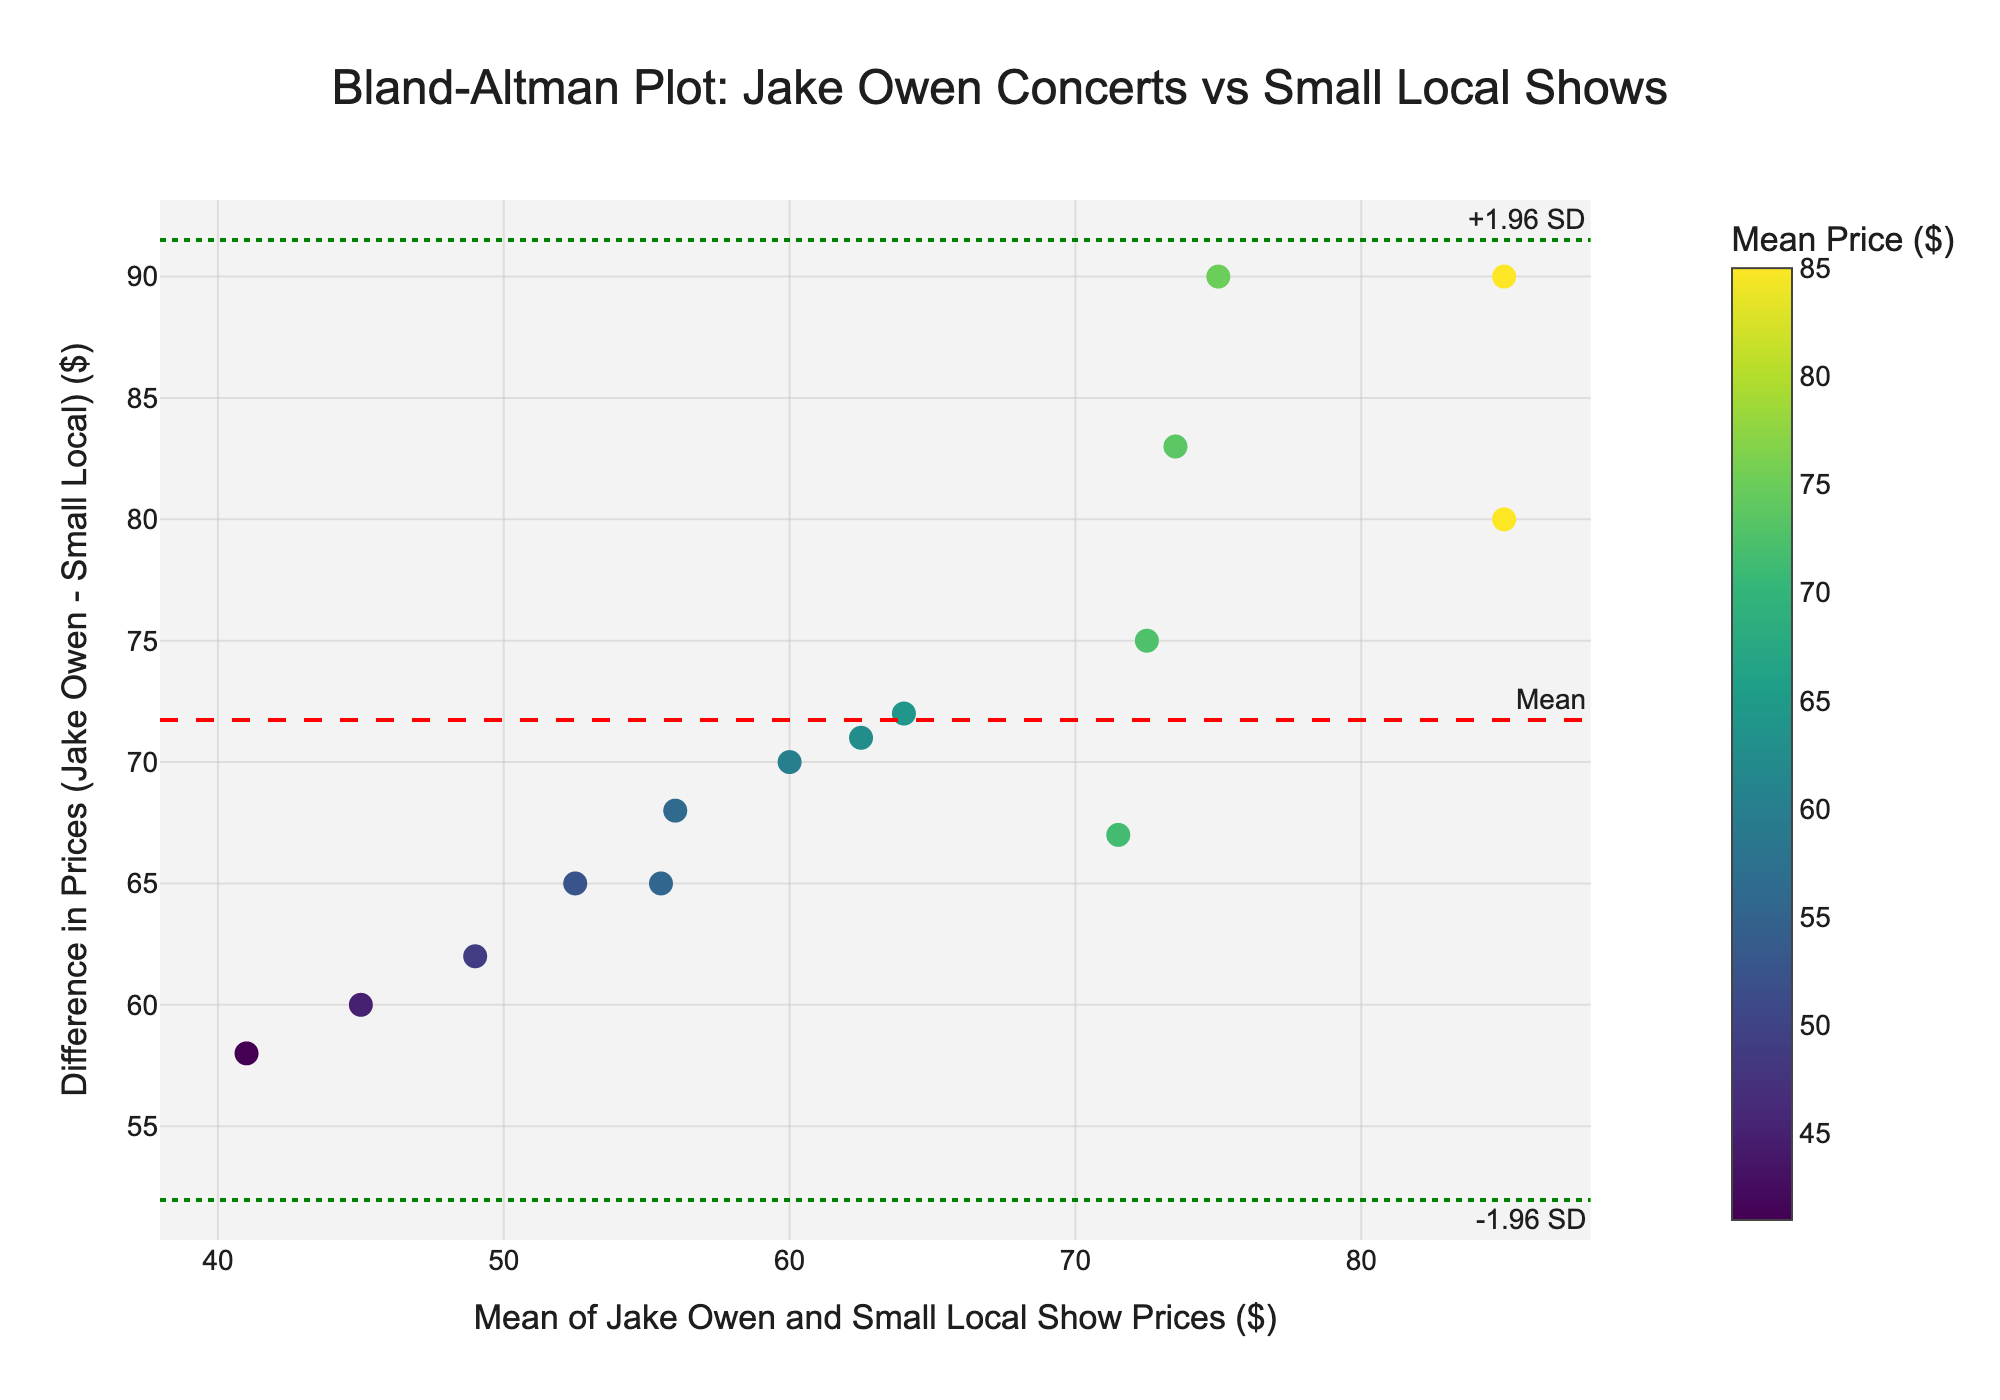What's the title of the plot? The title is displayed at the top of the plot, indicating what the plot is comparing.
Answer: "Bland-Altman Plot: Jake Owen Concerts vs Small Local Shows" How many data points are shown in the plot? Count the individual markers representing each pair of ticket prices.
Answer: 15 What do the red dashed and green dotted lines represent? The red dashed line represents the mean of the differences, while the green dotted lines represent ±1.96 standard deviations from the mean.
Answer: Mean and ±1.96 SD What's the difference in prices for the data point with the highest mean value? Look for the data point with the highest mean value on the x-axis and read its corresponding y-axis value.
Answer: 80 What is the average price of Jake Owen concerts and small local shows as grouped in the plot title? Sum all average prices and divide by the number of data points. (60+75+52.5+72.5+45+85+64+56+73.5+49+71.5+41+85+62.5+55.5)/15 = 63.3
Answer: 63.3 Which data point has the smallest difference in prices? Identify the data point closest to the horizontal axis at y=0.
Answer: 1 Does the plot show any trend where differences increase as mean prices increase? Check the overall distribution of the data points to see if higher means correlate with larger price differences.
Answer: No significant trend What is the range of mean values displayed on the x-axis? Identify the minimum and maximum values displayed on the x-axis.
Answer: 41 to 85 On average, are Jake Owen concert prices consistently higher than small local shows? Assess the position of most data points relative to the horizontal axis (positive y-values indicate Jake Owen concerts are more expensive).
Answer: Yes What's the approximate mean difference of ticket prices between Jake Owen concerts and small local shows as indicated by the red dashed line? Read the horizontal position of the red dashed line on the y-axis.
Answer: 67 